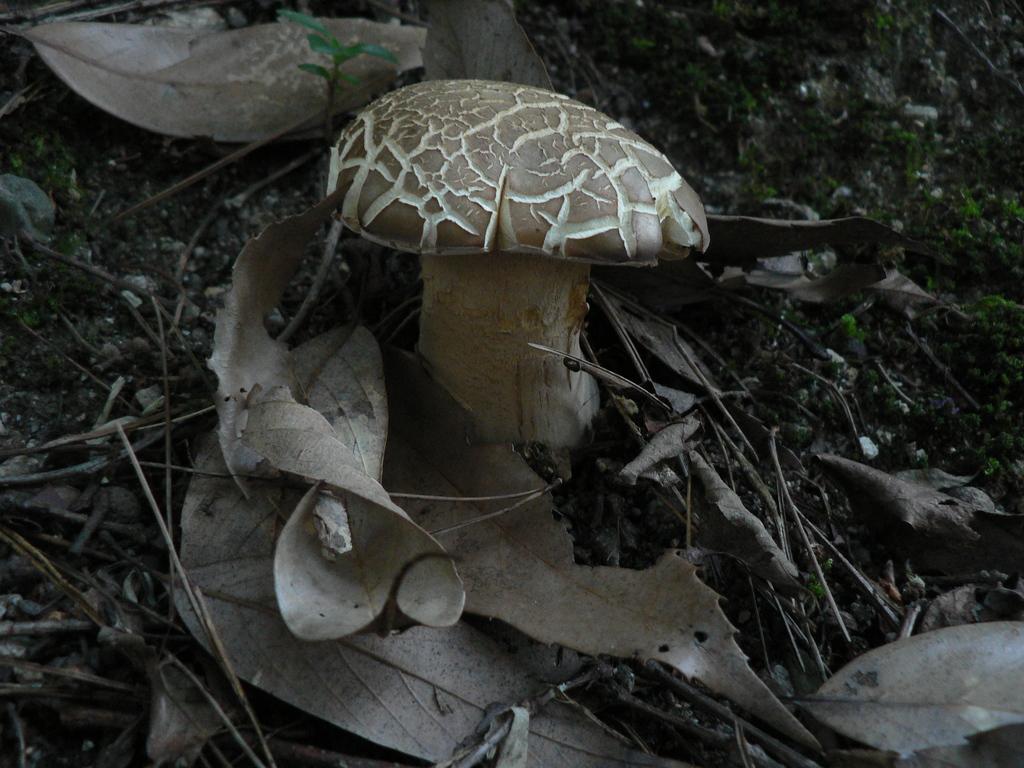In one or two sentences, can you explain what this image depicts? In the center of the image we can see a mushroom. At the bottom there are leaves and we can see twigs. 